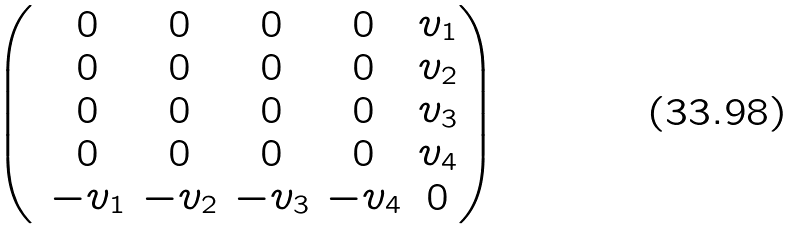Convert formula to latex. <formula><loc_0><loc_0><loc_500><loc_500>\begin{pmatrix} & 0 & 0 & 0 & 0 & v _ { 1 } \\ & 0 & 0 & 0 & 0 & v _ { 2 } \\ & 0 & 0 & 0 & 0 & v _ { 3 } \\ & 0 & 0 & 0 & 0 & v _ { 4 } \\ & - v _ { 1 } & - v _ { 2 } & - v _ { 3 } & - v _ { 4 } & 0 \\ \end{pmatrix}</formula> 